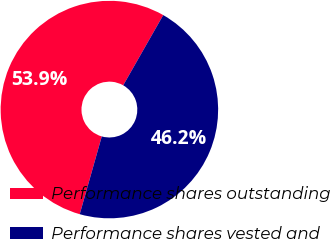<chart> <loc_0><loc_0><loc_500><loc_500><pie_chart><fcel>Performance shares outstanding<fcel>Performance shares vested and<nl><fcel>53.85%<fcel>46.15%<nl></chart> 